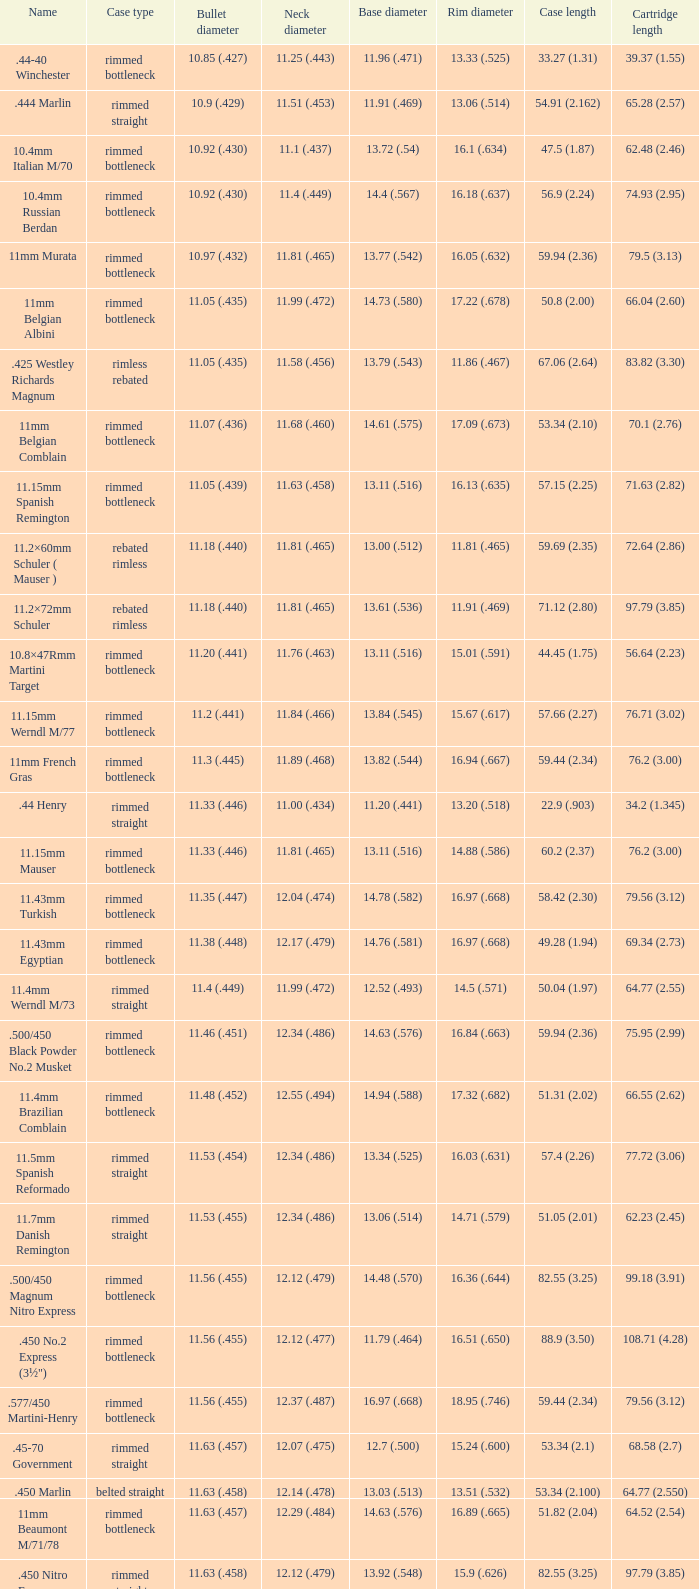Which case variety has a base diameter of 1 Belted straight. 